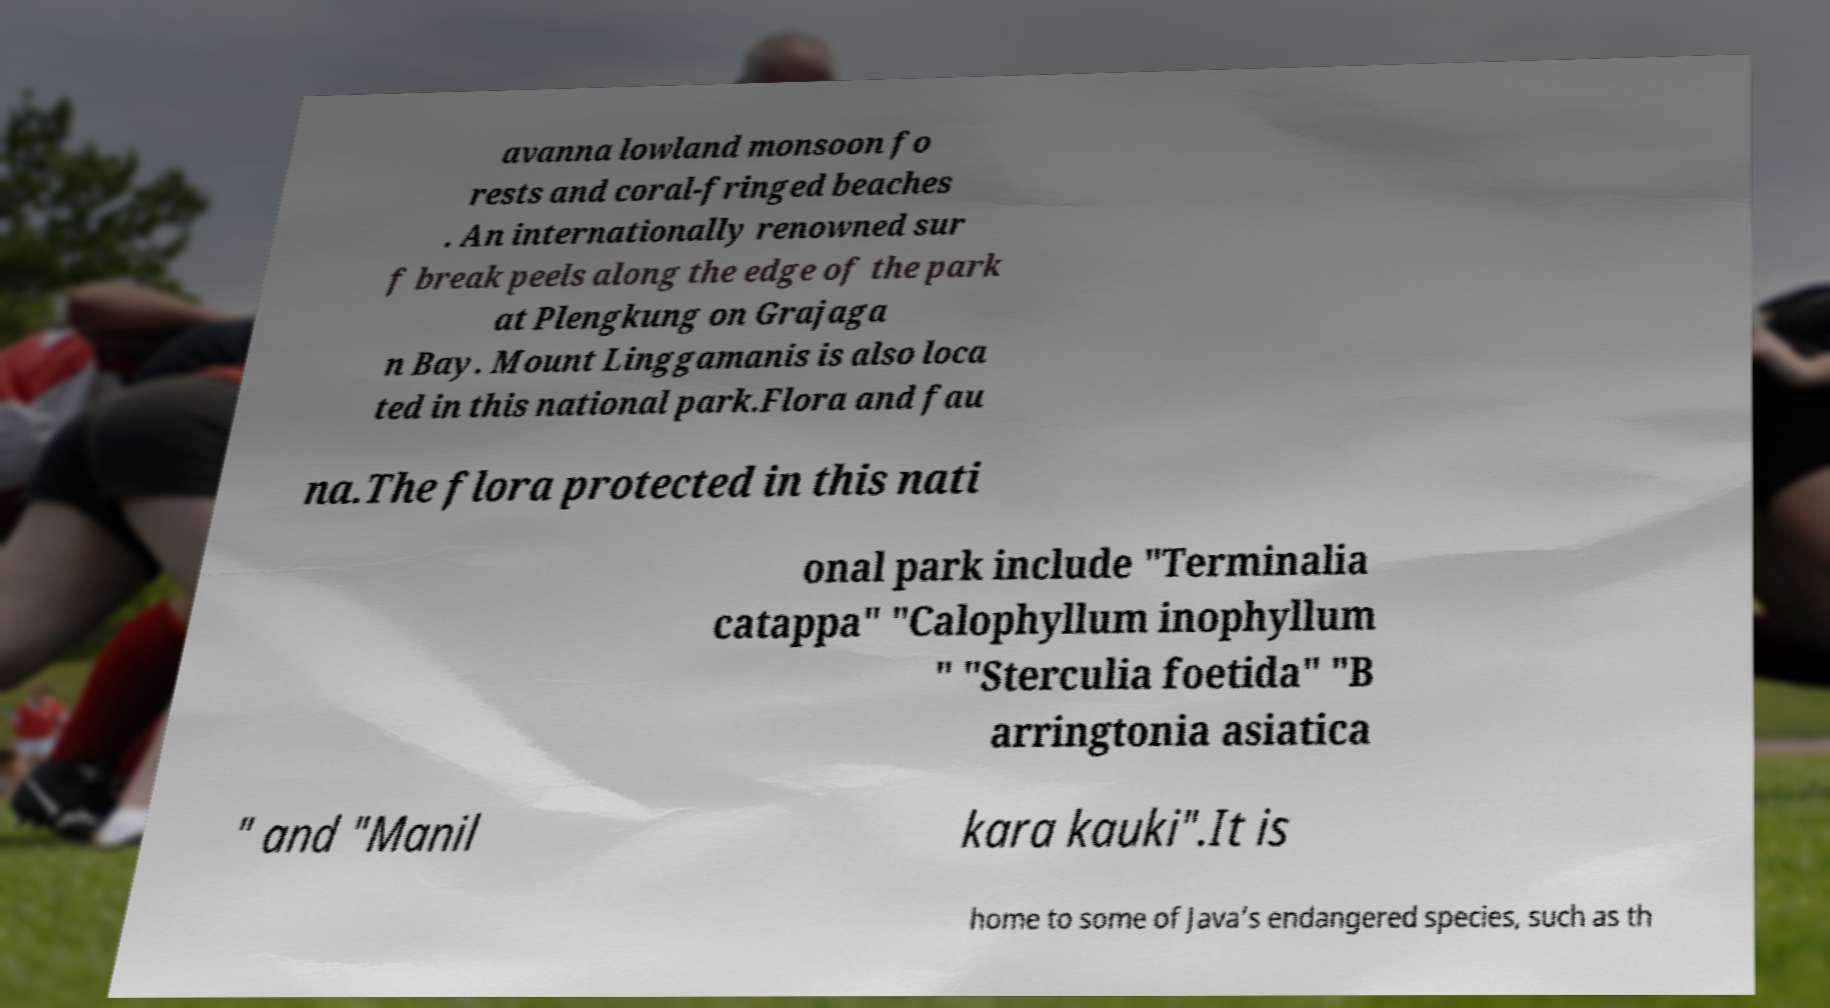For documentation purposes, I need the text within this image transcribed. Could you provide that? avanna lowland monsoon fo rests and coral-fringed beaches . An internationally renowned sur f break peels along the edge of the park at Plengkung on Grajaga n Bay. Mount Linggamanis is also loca ted in this national park.Flora and fau na.The flora protected in this nati onal park include "Terminalia catappa" "Calophyllum inophyllum " "Sterculia foetida" "B arringtonia asiatica " and "Manil kara kauki".It is home to some of Java’s endangered species, such as th 